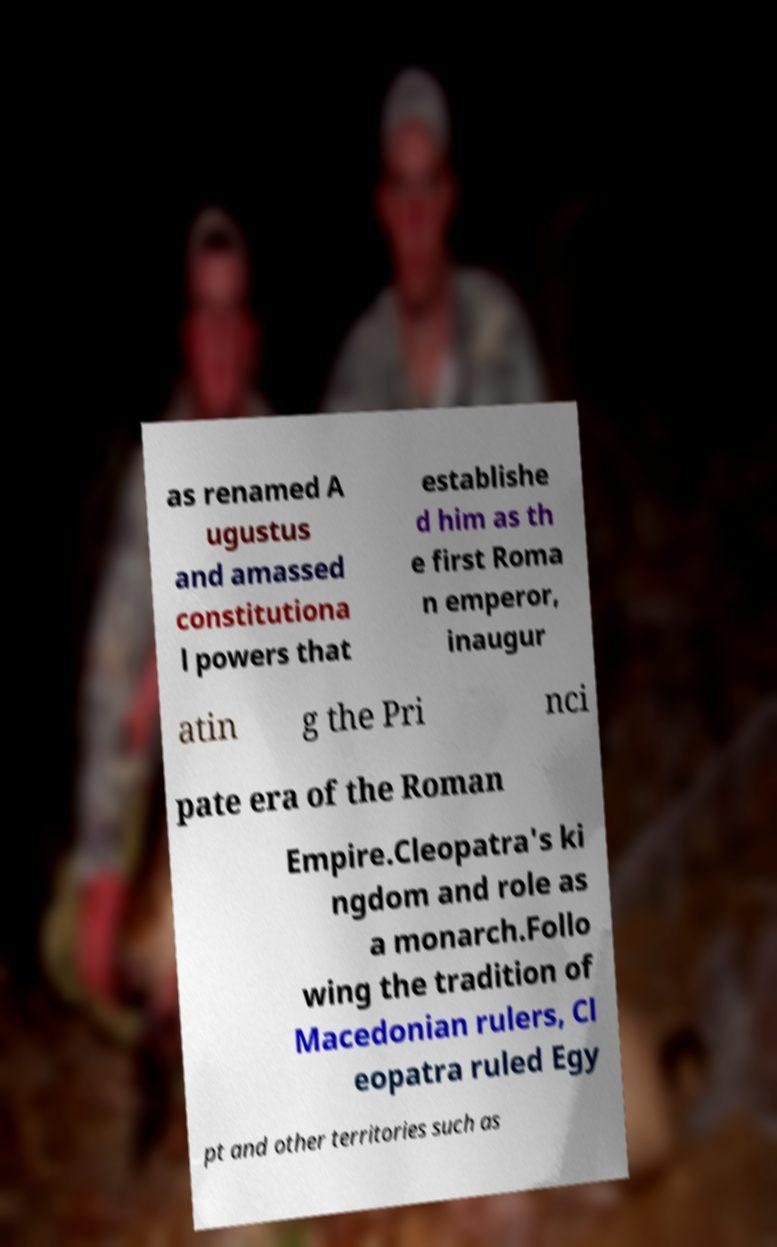Could you extract and type out the text from this image? as renamed A ugustus and amassed constitutiona l powers that establishe d him as th e first Roma n emperor, inaugur atin g the Pri nci pate era of the Roman Empire.Cleopatra's ki ngdom and role as a monarch.Follo wing the tradition of Macedonian rulers, Cl eopatra ruled Egy pt and other territories such as 